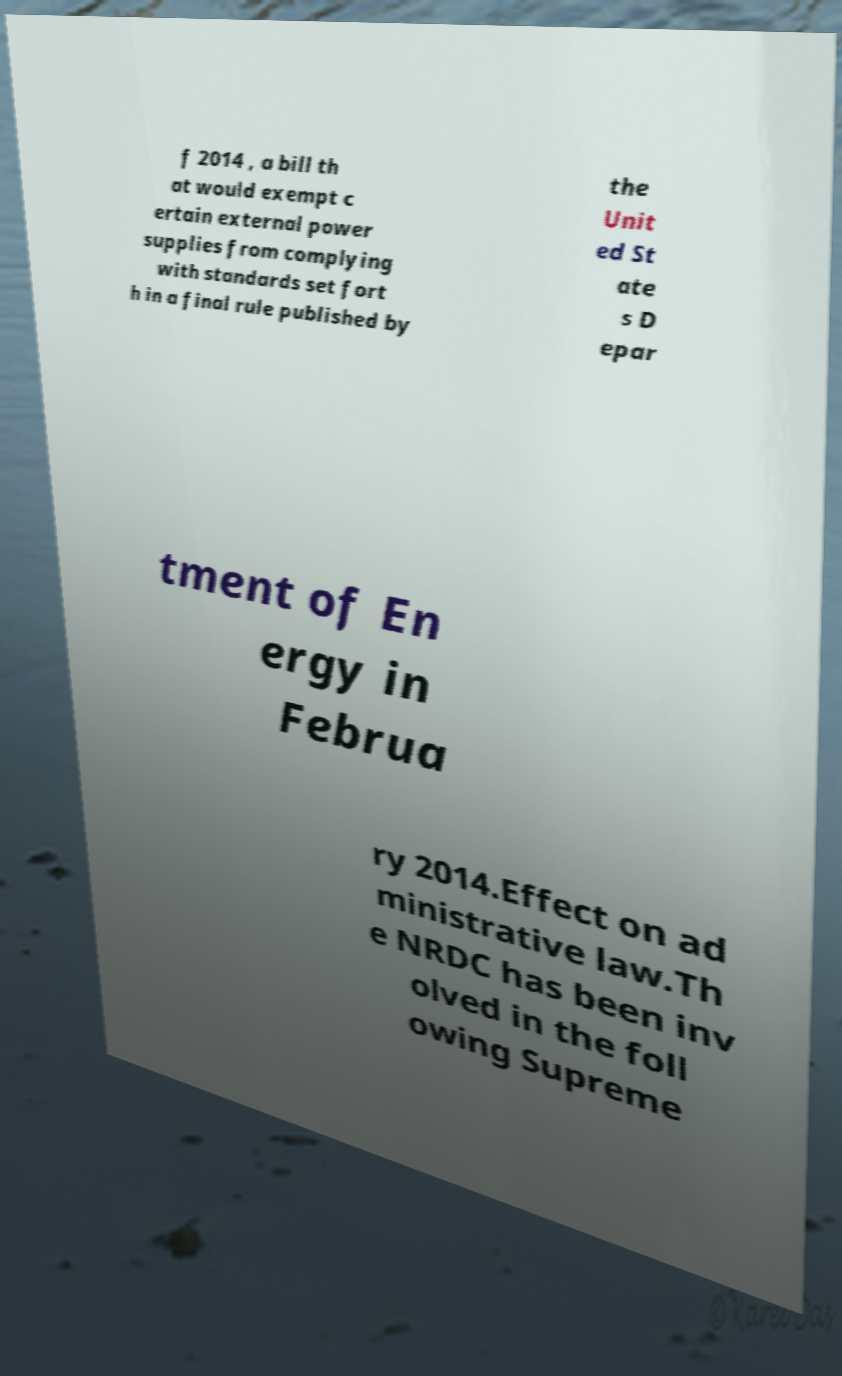Please read and relay the text visible in this image. What does it say? f 2014 , a bill th at would exempt c ertain external power supplies from complying with standards set fort h in a final rule published by the Unit ed St ate s D epar tment of En ergy in Februa ry 2014.Effect on ad ministrative law.Th e NRDC has been inv olved in the foll owing Supreme 